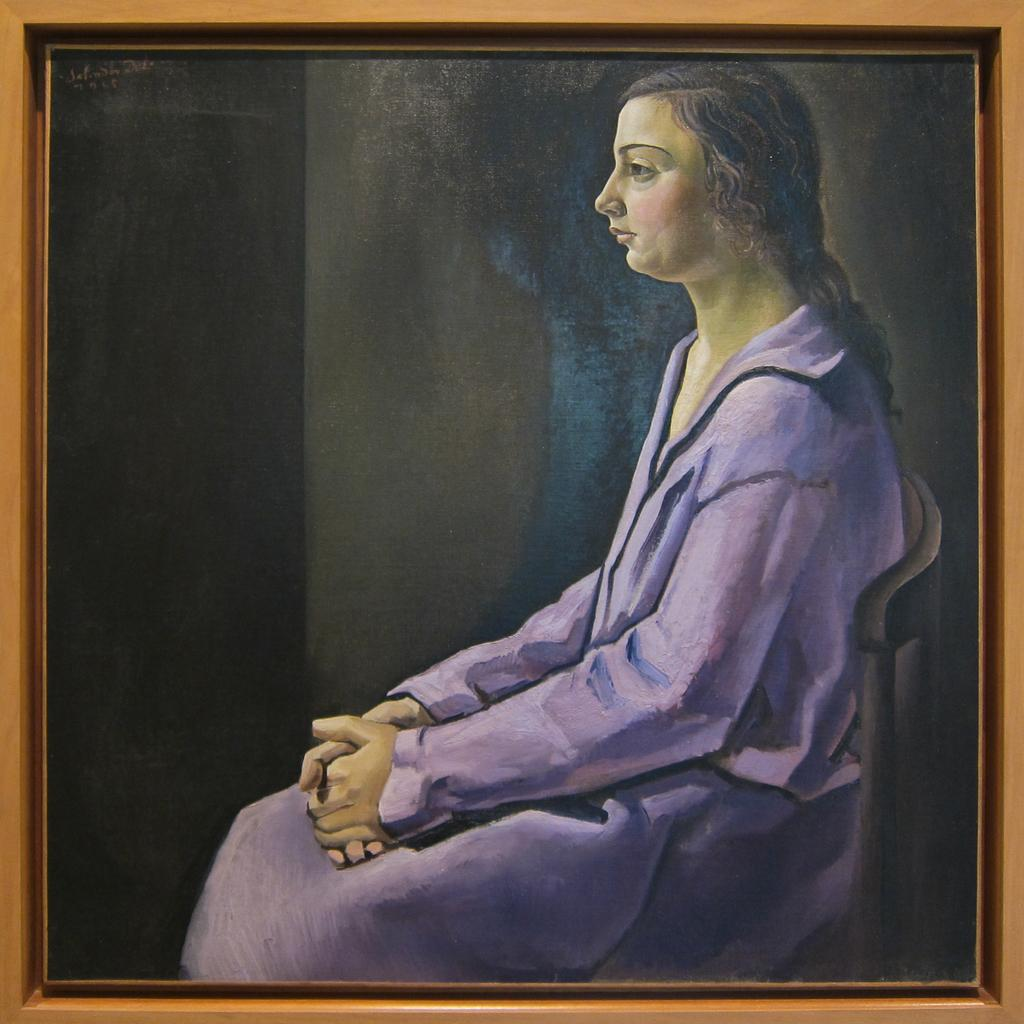What is the main subject of the painting in the image? The painting depicts a woman. What is the woman wearing in the painting? The woman is wearing a dress in the painting. Where is the woman sitting in the painting? The woman is sitting near a wall in the painting. What type of oven can be seen in the painting? There is no oven present in the painting; it depicts a woman sitting near a wall. How many snakes are slithering around the woman in the painting? There are no snakes present in the painting; it depicts a woman sitting near a wall. 